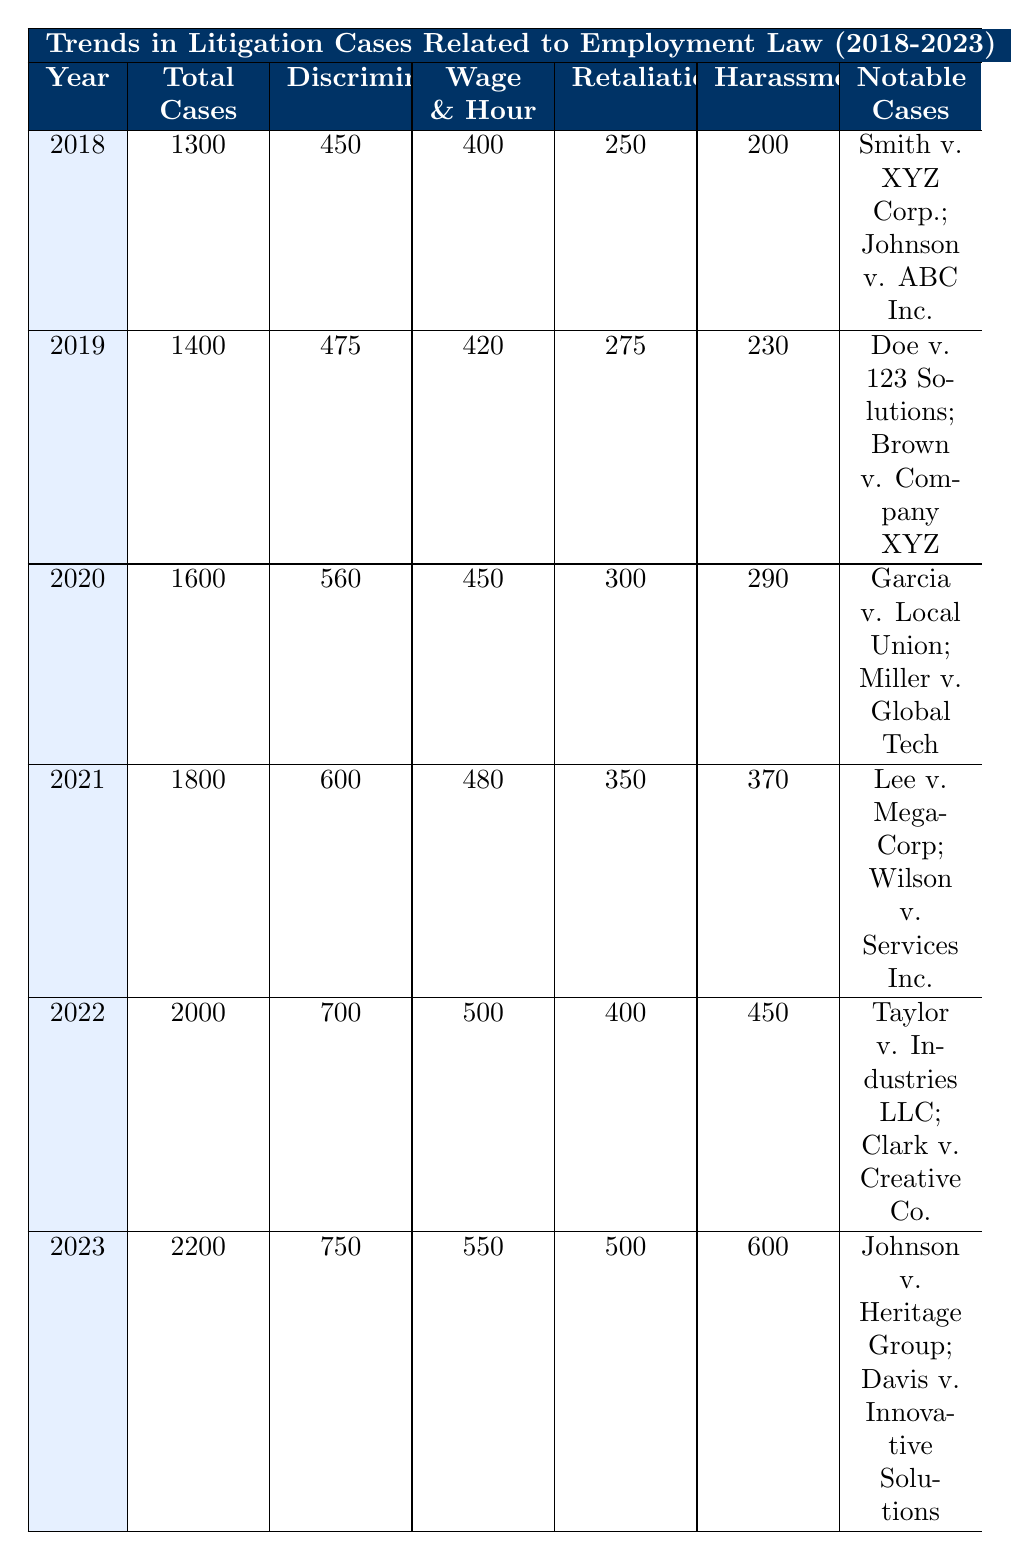What was the total number of litigation cases filed in 2022? From the table, in the year 2022, the column for Total Cases indicates that there were 2000 cases filed that year.
Answer: 2000 How many Discrimination Cases were filed in 2021? The Discrimination Cases column for the year 2021 shows that there were 600 cases filed.
Answer: 600 What is the percentage increase in Total Cases from 2018 to 2023? The total cases in 2018 were 1300 and in 2023 were 2200. The increase is (2200 - 1300) = 900. To find the percentage increase: (900 / 1300) * 100 = 69.23%.
Answer: 69.23% Is it true that Retaliation Cases peaked in 2021? Looking at the Retaliation Cases column, the highest number is 350 in 2021. Comparing it with other years, it does not exceed this value in any other year.
Answer: Yes What is the average number of Wage and Hour Cases from 2019 to 2023? The number of Wage and Hour Cases from 2019 to 2023 are 420, 450, 480, 500, and 550 respectively. Summing these values gives 2400. Since there are 5 years, the average is 2400 / 5 = 480.
Answer: 480 How many more Harassment Cases were filed in 2023 than in 2018? In 2023, there were 600 Harassment Cases and in 2018 there were 200. The difference is 600 - 200 = 400.
Answer: 400 Which year had the most notable cases listed? By inspecting the Notable Cases column, it shows notable cases listed for each year, so there is no defined maximum. However, years 2022 and 2023 have two notable cases listed, same as others yet it does not specify the significance of each case, making it ambiguous.
Answer: Not specified What is the trend of Discrimination Cases from 2018 to 2023? Analyzing the Discrimination Cases column, 450 in 2018, rising to 750 in 2023 shows a consistent upward trend each year.
Answer: Upward trend What was the total number of cases filed across all years from 2018 to 2023? Adding total cases filed per year: 1300 + 1400 + 1600 + 1800 + 2000 + 2200 = 11500.
Answer: 11500 